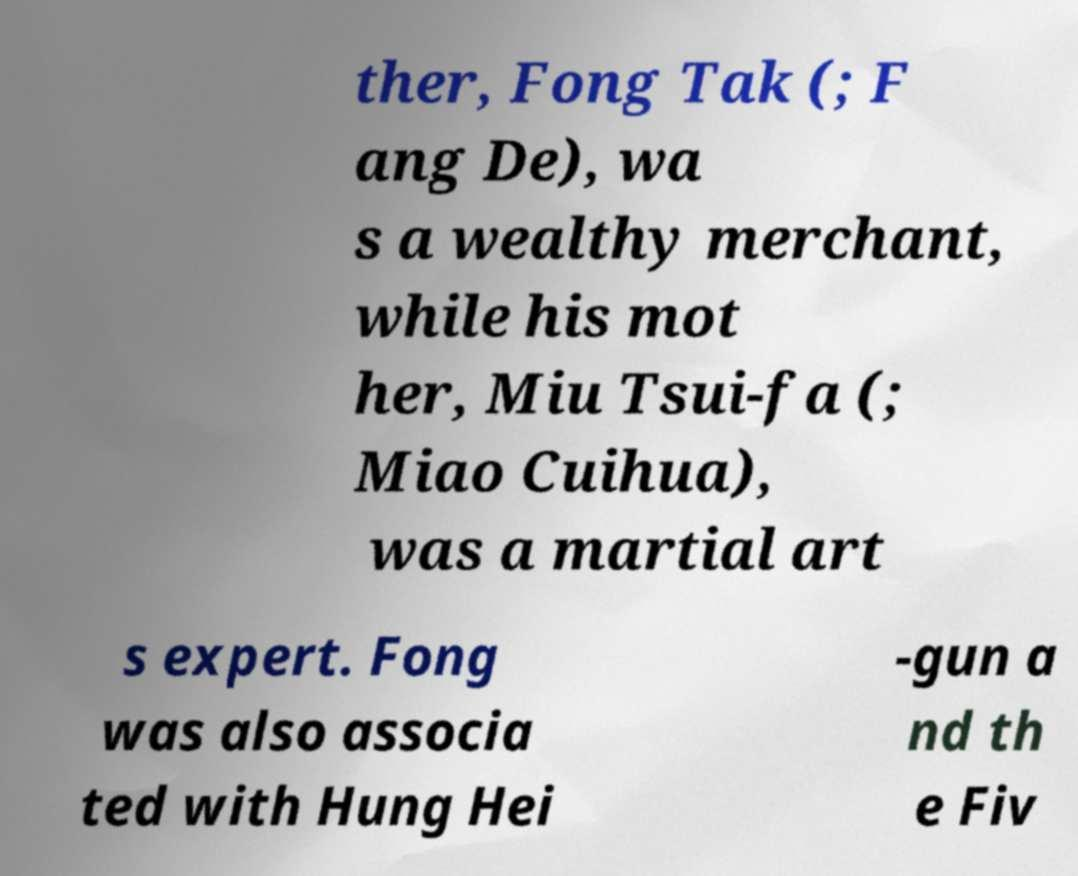Please read and relay the text visible in this image. What does it say? ther, Fong Tak (; F ang De), wa s a wealthy merchant, while his mot her, Miu Tsui-fa (; Miao Cuihua), was a martial art s expert. Fong was also associa ted with Hung Hei -gun a nd th e Fiv 